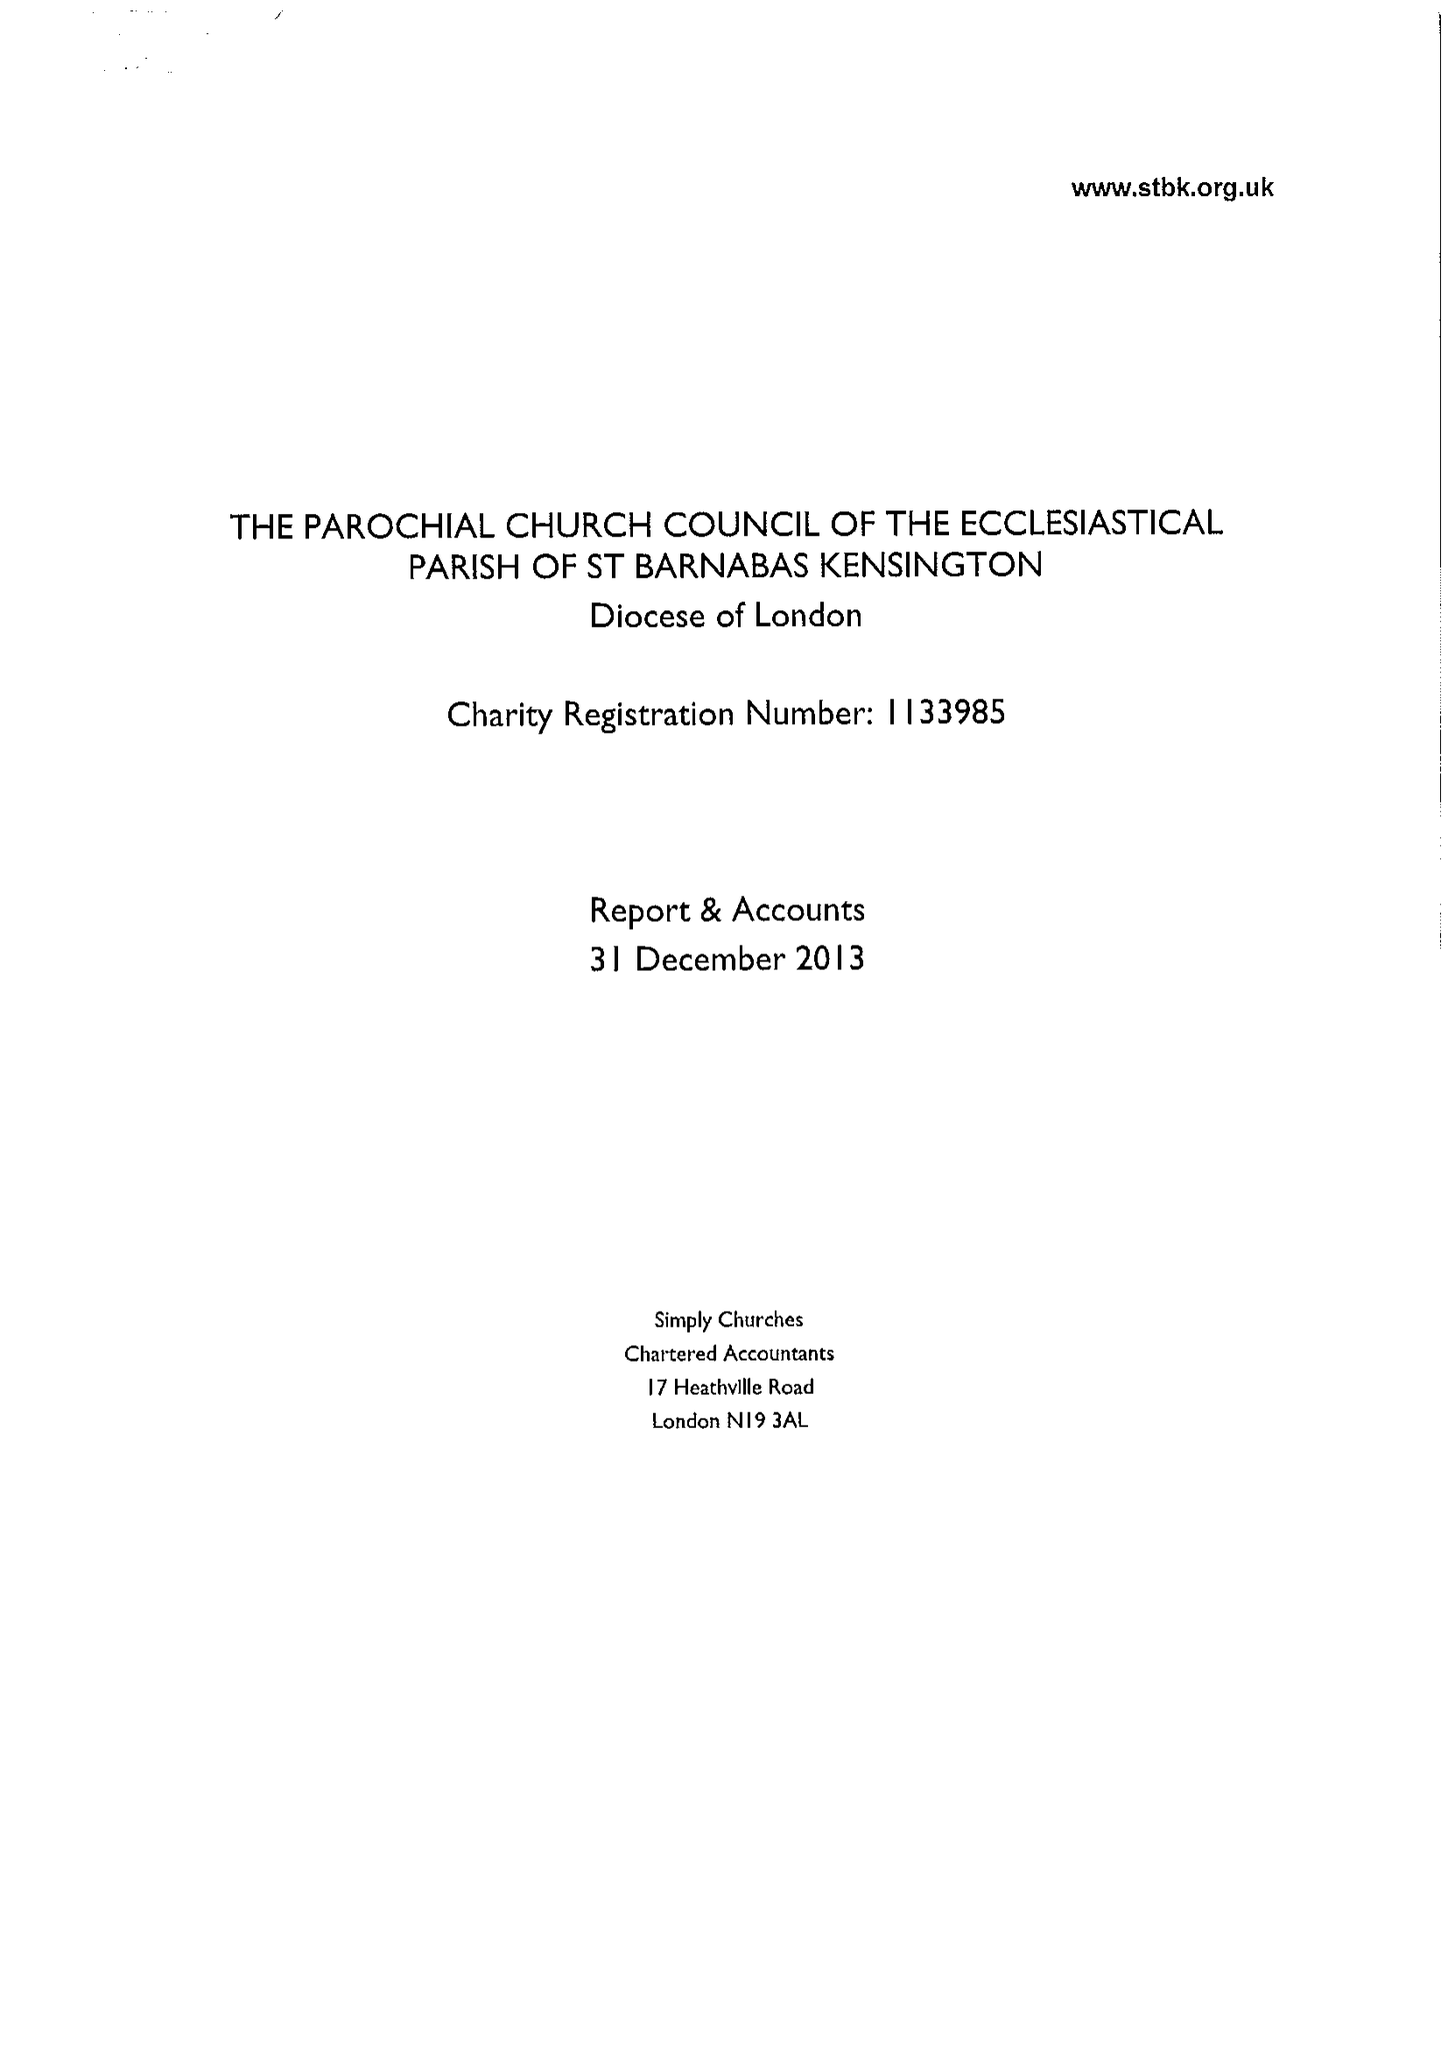What is the value for the spending_annually_in_british_pounds?
Answer the question using a single word or phrase. 522539.00 